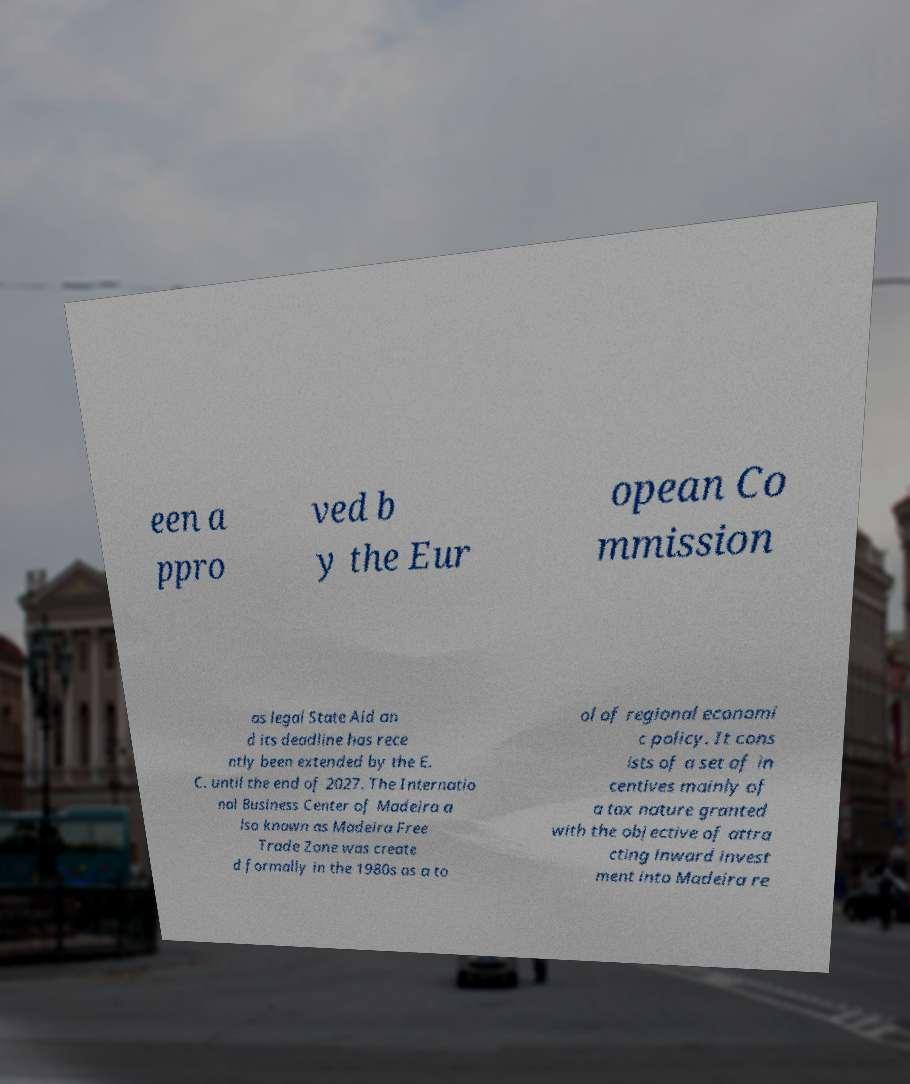Could you assist in decoding the text presented in this image and type it out clearly? een a ppro ved b y the Eur opean Co mmission as legal State Aid an d its deadline has rece ntly been extended by the E. C. until the end of 2027. The Internatio nal Business Center of Madeira a lso known as Madeira Free Trade Zone was create d formally in the 1980s as a to ol of regional economi c policy. It cons ists of a set of in centives mainly of a tax nature granted with the objective of attra cting inward invest ment into Madeira re 